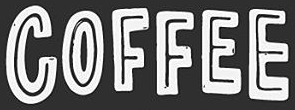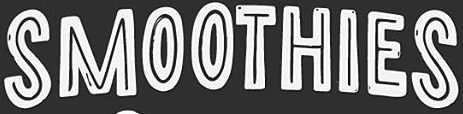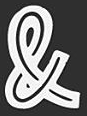Identify the words shown in these images in order, separated by a semicolon. COFFEE; SMOOTHIES; & 